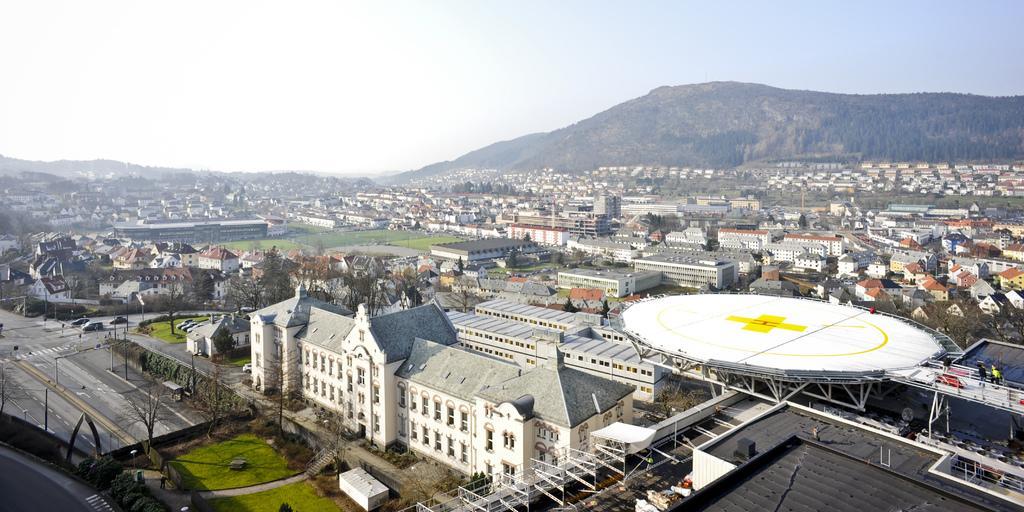Could you give a brief overview of what you see in this image? In the image there are many buildings and houses with roofs, walls and windows. And also there is a helipad in between them. On the left of the image there is a roads and poles with lights. And in the background there are hills. At the top of the image there is a sky. 